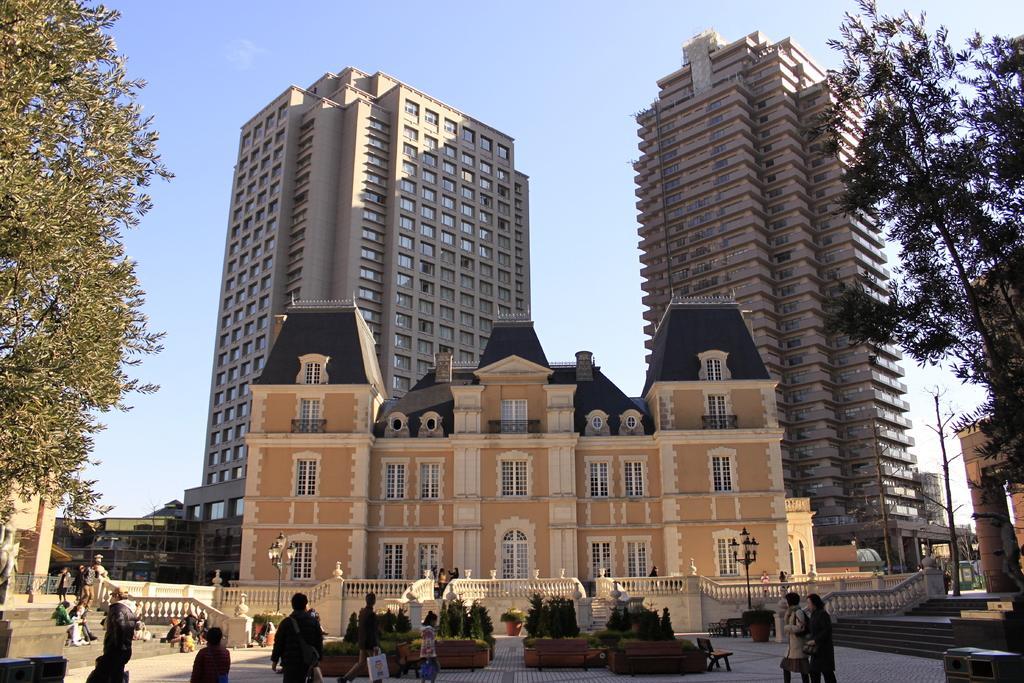Could you give a brief overview of what you see in this image? In this image I can see number of people and I can see few of them are sitting on stairs and few are standing. I can see one of them is carrying a bag. In the background I can see number of trees, number of buildings, plants, bench and sky. I can also see shadows on ground. 